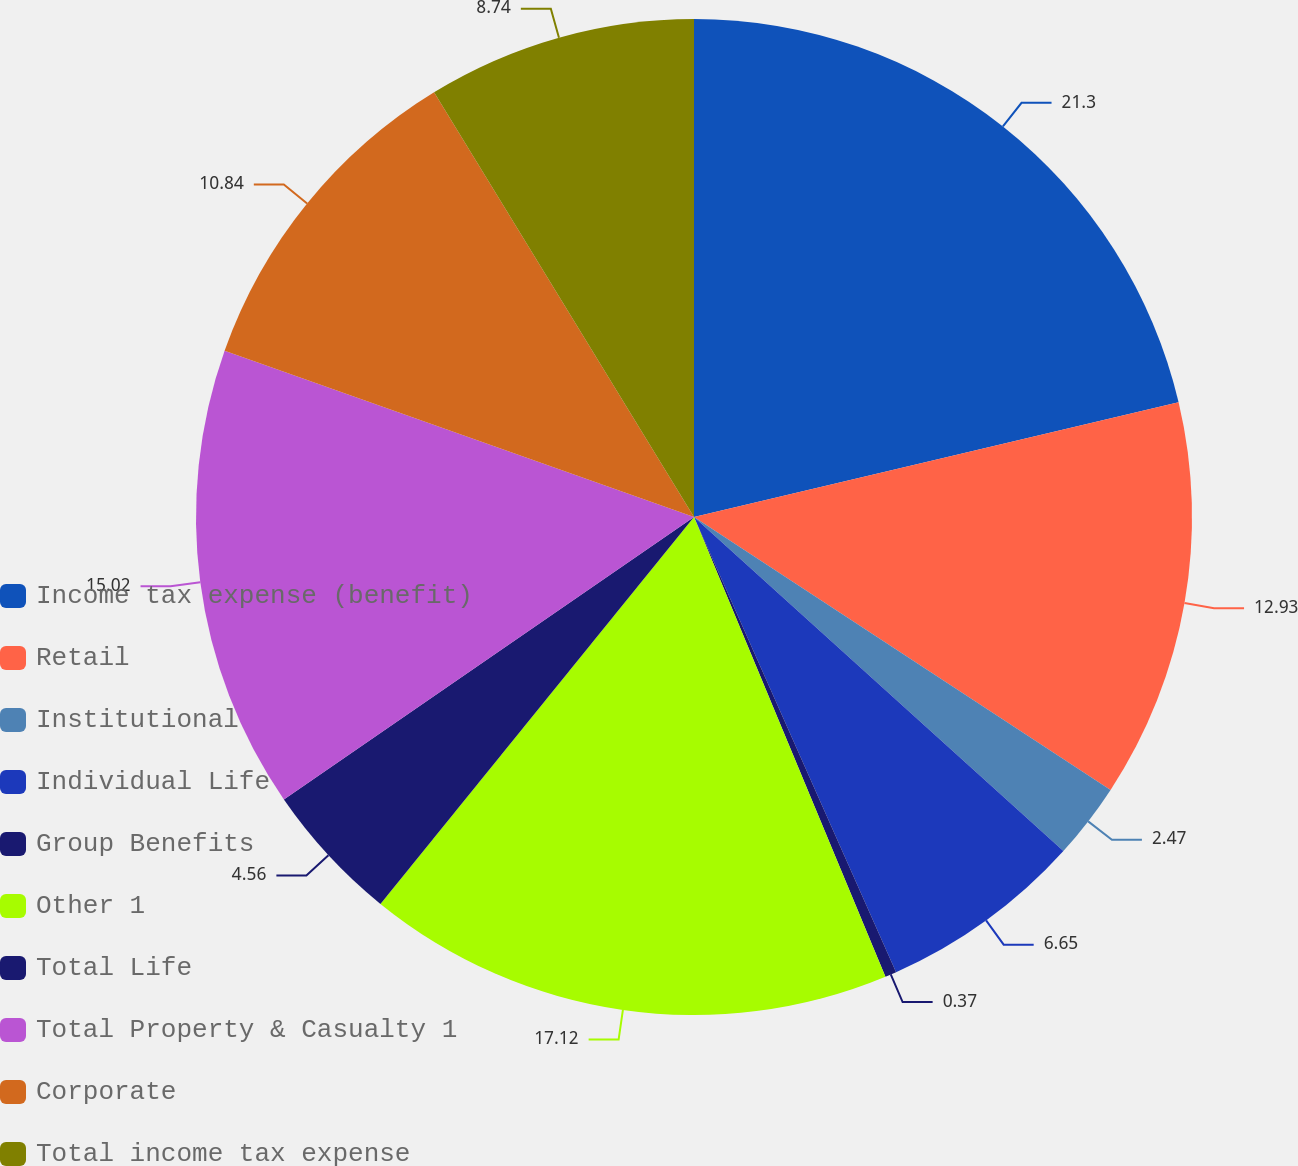<chart> <loc_0><loc_0><loc_500><loc_500><pie_chart><fcel>Income tax expense (benefit)<fcel>Retail<fcel>Institutional<fcel>Individual Life<fcel>Group Benefits<fcel>Other 1<fcel>Total Life<fcel>Total Property & Casualty 1<fcel>Corporate<fcel>Total income tax expense<nl><fcel>21.3%<fcel>12.93%<fcel>2.47%<fcel>6.65%<fcel>0.37%<fcel>17.12%<fcel>4.56%<fcel>15.02%<fcel>10.84%<fcel>8.74%<nl></chart> 